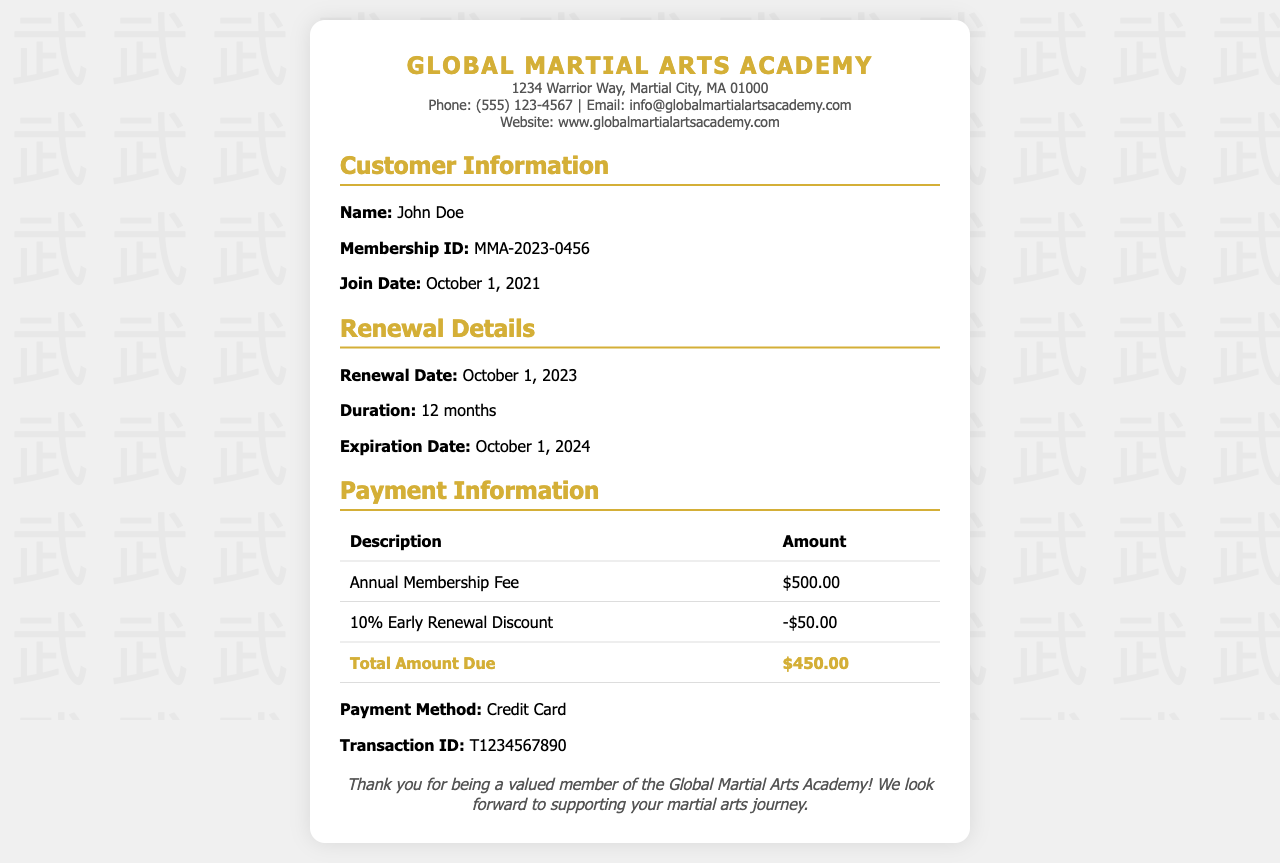What is the name of the academy? The name of the academy is mentioned in the header section of the receipt.
Answer: Global Martial Arts Academy Who is the customer? The customer for this membership renewal is stated under customer details.
Answer: John Doe What is the membership ID? The membership ID is provided in the customer details section of the receipt.
Answer: MMA-2023-0456 What is the renewal date? The renewal date can be found in the renewal details section.
Answer: October 1, 2023 What is the total amount due? The total amount due is calculated after applying discounts, located in the payment details section.
Answer: $450.00 What discount was applied? The applied discount is clearly shown in the payment details section.
Answer: 10% Early Renewal Discount What is the duration of the renewed membership? The duration of the renewed membership is specified in the renewal details section.
Answer: 12 months What is the expiration date of the new membership? The expiration date is given in the renewal details section of the document.
Answer: October 1, 2024 What payment method was used? The payment method is mentioned in the payment details section of the receipt.
Answer: Credit Card 